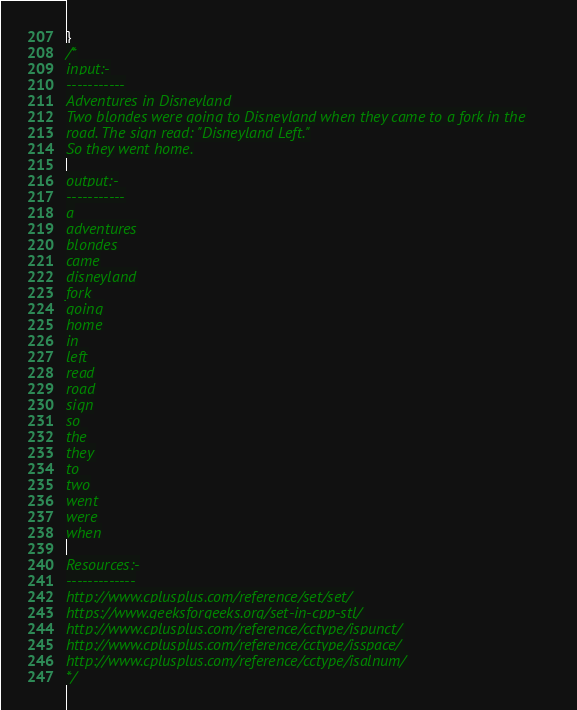<code> <loc_0><loc_0><loc_500><loc_500><_C++_>}
/*
input:-
-----------
Adventures in Disneyland
Two blondes were going to Disneyland when they came to a fork in the
road. The sign read: "Disneyland Left."
So they went home.

output:-
-----------
a
adventures
blondes
came
disneyland
fork
going
home
in
left
read
road
sign
so
the
they
to
two
went
were
when

Resources:-
-------------
http://www.cplusplus.com/reference/set/set/
https://www.geeksforgeeks.org/set-in-cpp-stl/
http://www.cplusplus.com/reference/cctype/ispunct/
http://www.cplusplus.com/reference/cctype/isspace/
http://www.cplusplus.com/reference/cctype/isalnum/
*/
</code> 